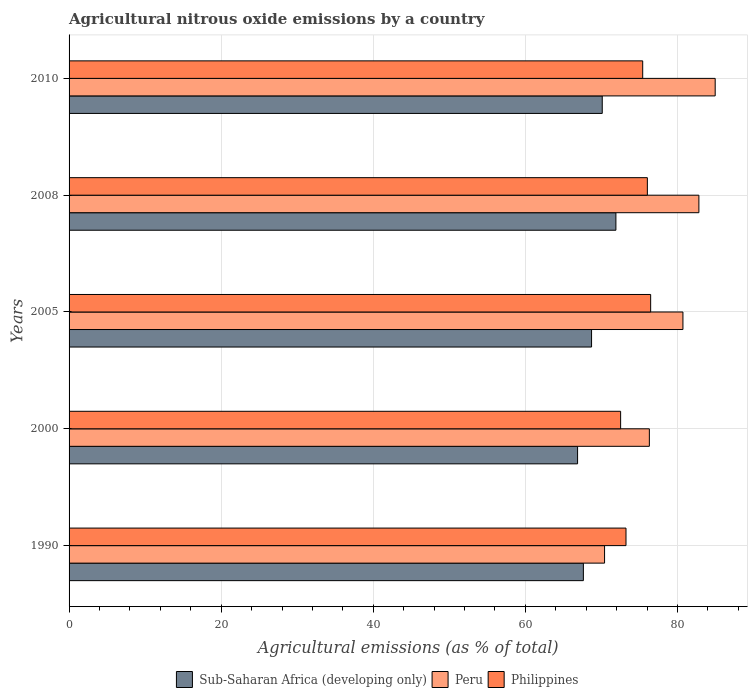Are the number of bars on each tick of the Y-axis equal?
Give a very brief answer. Yes. How many bars are there on the 2nd tick from the top?
Keep it short and to the point. 3. How many bars are there on the 5th tick from the bottom?
Give a very brief answer. 3. What is the label of the 1st group of bars from the top?
Your answer should be very brief. 2010. In how many cases, is the number of bars for a given year not equal to the number of legend labels?
Make the answer very short. 0. What is the amount of agricultural nitrous oxide emitted in Peru in 2010?
Provide a short and direct response. 84.95. Across all years, what is the maximum amount of agricultural nitrous oxide emitted in Peru?
Your answer should be compact. 84.95. Across all years, what is the minimum amount of agricultural nitrous oxide emitted in Sub-Saharan Africa (developing only)?
Your response must be concise. 66.86. In which year was the amount of agricultural nitrous oxide emitted in Philippines minimum?
Your response must be concise. 2000. What is the total amount of agricultural nitrous oxide emitted in Philippines in the graph?
Provide a short and direct response. 373.66. What is the difference between the amount of agricultural nitrous oxide emitted in Sub-Saharan Africa (developing only) in 2005 and that in 2008?
Your response must be concise. -3.2. What is the difference between the amount of agricultural nitrous oxide emitted in Peru in 2010 and the amount of agricultural nitrous oxide emitted in Sub-Saharan Africa (developing only) in 2008?
Make the answer very short. 13.05. What is the average amount of agricultural nitrous oxide emitted in Peru per year?
Provide a short and direct response. 79.03. In the year 2008, what is the difference between the amount of agricultural nitrous oxide emitted in Peru and amount of agricultural nitrous oxide emitted in Sub-Saharan Africa (developing only)?
Give a very brief answer. 10.91. In how many years, is the amount of agricultural nitrous oxide emitted in Philippines greater than 68 %?
Ensure brevity in your answer.  5. What is the ratio of the amount of agricultural nitrous oxide emitted in Sub-Saharan Africa (developing only) in 2005 to that in 2008?
Provide a short and direct response. 0.96. Is the amount of agricultural nitrous oxide emitted in Peru in 2000 less than that in 2008?
Give a very brief answer. Yes. What is the difference between the highest and the second highest amount of agricultural nitrous oxide emitted in Peru?
Provide a succinct answer. 2.14. What is the difference between the highest and the lowest amount of agricultural nitrous oxide emitted in Sub-Saharan Africa (developing only)?
Provide a succinct answer. 5.04. In how many years, is the amount of agricultural nitrous oxide emitted in Peru greater than the average amount of agricultural nitrous oxide emitted in Peru taken over all years?
Offer a terse response. 3. Is the sum of the amount of agricultural nitrous oxide emitted in Philippines in 1990 and 2005 greater than the maximum amount of agricultural nitrous oxide emitted in Peru across all years?
Make the answer very short. Yes. What does the 2nd bar from the bottom in 2000 represents?
Give a very brief answer. Peru. Is it the case that in every year, the sum of the amount of agricultural nitrous oxide emitted in Peru and amount of agricultural nitrous oxide emitted in Sub-Saharan Africa (developing only) is greater than the amount of agricultural nitrous oxide emitted in Philippines?
Offer a terse response. Yes. How many bars are there?
Keep it short and to the point. 15. Are all the bars in the graph horizontal?
Make the answer very short. Yes. What is the difference between two consecutive major ticks on the X-axis?
Ensure brevity in your answer.  20. Where does the legend appear in the graph?
Offer a terse response. Bottom center. What is the title of the graph?
Keep it short and to the point. Agricultural nitrous oxide emissions by a country. What is the label or title of the X-axis?
Provide a succinct answer. Agricultural emissions (as % of total). What is the Agricultural emissions (as % of total) of Sub-Saharan Africa (developing only) in 1990?
Your answer should be very brief. 67.62. What is the Agricultural emissions (as % of total) in Peru in 1990?
Offer a very short reply. 70.41. What is the Agricultural emissions (as % of total) of Philippines in 1990?
Offer a very short reply. 73.22. What is the Agricultural emissions (as % of total) in Sub-Saharan Africa (developing only) in 2000?
Your answer should be very brief. 66.86. What is the Agricultural emissions (as % of total) in Peru in 2000?
Offer a terse response. 76.3. What is the Agricultural emissions (as % of total) of Philippines in 2000?
Give a very brief answer. 72.52. What is the Agricultural emissions (as % of total) of Sub-Saharan Africa (developing only) in 2005?
Give a very brief answer. 68.7. What is the Agricultural emissions (as % of total) of Peru in 2005?
Provide a short and direct response. 80.71. What is the Agricultural emissions (as % of total) of Philippines in 2005?
Your response must be concise. 76.47. What is the Agricultural emissions (as % of total) of Sub-Saharan Africa (developing only) in 2008?
Offer a very short reply. 71.9. What is the Agricultural emissions (as % of total) of Peru in 2008?
Provide a short and direct response. 82.81. What is the Agricultural emissions (as % of total) of Philippines in 2008?
Ensure brevity in your answer.  76.03. What is the Agricultural emissions (as % of total) in Sub-Saharan Africa (developing only) in 2010?
Offer a terse response. 70.1. What is the Agricultural emissions (as % of total) of Peru in 2010?
Provide a short and direct response. 84.95. What is the Agricultural emissions (as % of total) in Philippines in 2010?
Keep it short and to the point. 75.42. Across all years, what is the maximum Agricultural emissions (as % of total) in Sub-Saharan Africa (developing only)?
Keep it short and to the point. 71.9. Across all years, what is the maximum Agricultural emissions (as % of total) in Peru?
Offer a very short reply. 84.95. Across all years, what is the maximum Agricultural emissions (as % of total) in Philippines?
Provide a succinct answer. 76.47. Across all years, what is the minimum Agricultural emissions (as % of total) in Sub-Saharan Africa (developing only)?
Offer a terse response. 66.86. Across all years, what is the minimum Agricultural emissions (as % of total) of Peru?
Ensure brevity in your answer.  70.41. Across all years, what is the minimum Agricultural emissions (as % of total) of Philippines?
Your answer should be very brief. 72.52. What is the total Agricultural emissions (as % of total) in Sub-Saharan Africa (developing only) in the graph?
Ensure brevity in your answer.  345.18. What is the total Agricultural emissions (as % of total) in Peru in the graph?
Your answer should be compact. 395.17. What is the total Agricultural emissions (as % of total) of Philippines in the graph?
Offer a very short reply. 373.66. What is the difference between the Agricultural emissions (as % of total) of Sub-Saharan Africa (developing only) in 1990 and that in 2000?
Your answer should be very brief. 0.76. What is the difference between the Agricultural emissions (as % of total) of Peru in 1990 and that in 2000?
Provide a short and direct response. -5.89. What is the difference between the Agricultural emissions (as % of total) of Philippines in 1990 and that in 2000?
Your response must be concise. 0.71. What is the difference between the Agricultural emissions (as % of total) in Sub-Saharan Africa (developing only) in 1990 and that in 2005?
Offer a terse response. -1.08. What is the difference between the Agricultural emissions (as % of total) in Peru in 1990 and that in 2005?
Offer a very short reply. -10.3. What is the difference between the Agricultural emissions (as % of total) in Philippines in 1990 and that in 2005?
Your response must be concise. -3.24. What is the difference between the Agricultural emissions (as % of total) of Sub-Saharan Africa (developing only) in 1990 and that in 2008?
Ensure brevity in your answer.  -4.28. What is the difference between the Agricultural emissions (as % of total) of Peru in 1990 and that in 2008?
Provide a succinct answer. -12.4. What is the difference between the Agricultural emissions (as % of total) of Philippines in 1990 and that in 2008?
Your answer should be very brief. -2.81. What is the difference between the Agricultural emissions (as % of total) of Sub-Saharan Africa (developing only) in 1990 and that in 2010?
Keep it short and to the point. -2.48. What is the difference between the Agricultural emissions (as % of total) in Peru in 1990 and that in 2010?
Give a very brief answer. -14.54. What is the difference between the Agricultural emissions (as % of total) in Philippines in 1990 and that in 2010?
Provide a succinct answer. -2.2. What is the difference between the Agricultural emissions (as % of total) in Sub-Saharan Africa (developing only) in 2000 and that in 2005?
Offer a very short reply. -1.84. What is the difference between the Agricultural emissions (as % of total) in Peru in 2000 and that in 2005?
Your answer should be compact. -4.41. What is the difference between the Agricultural emissions (as % of total) in Philippines in 2000 and that in 2005?
Provide a short and direct response. -3.95. What is the difference between the Agricultural emissions (as % of total) of Sub-Saharan Africa (developing only) in 2000 and that in 2008?
Offer a terse response. -5.04. What is the difference between the Agricultural emissions (as % of total) in Peru in 2000 and that in 2008?
Provide a succinct answer. -6.51. What is the difference between the Agricultural emissions (as % of total) of Philippines in 2000 and that in 2008?
Give a very brief answer. -3.52. What is the difference between the Agricultural emissions (as % of total) in Sub-Saharan Africa (developing only) in 2000 and that in 2010?
Offer a very short reply. -3.24. What is the difference between the Agricultural emissions (as % of total) of Peru in 2000 and that in 2010?
Offer a terse response. -8.65. What is the difference between the Agricultural emissions (as % of total) of Philippines in 2000 and that in 2010?
Ensure brevity in your answer.  -2.9. What is the difference between the Agricultural emissions (as % of total) in Sub-Saharan Africa (developing only) in 2005 and that in 2008?
Offer a terse response. -3.2. What is the difference between the Agricultural emissions (as % of total) in Peru in 2005 and that in 2008?
Make the answer very short. -2.1. What is the difference between the Agricultural emissions (as % of total) of Philippines in 2005 and that in 2008?
Offer a very short reply. 0.43. What is the difference between the Agricultural emissions (as % of total) in Sub-Saharan Africa (developing only) in 2005 and that in 2010?
Give a very brief answer. -1.41. What is the difference between the Agricultural emissions (as % of total) of Peru in 2005 and that in 2010?
Offer a terse response. -4.24. What is the difference between the Agricultural emissions (as % of total) of Philippines in 2005 and that in 2010?
Your answer should be very brief. 1.05. What is the difference between the Agricultural emissions (as % of total) of Sub-Saharan Africa (developing only) in 2008 and that in 2010?
Your answer should be compact. 1.79. What is the difference between the Agricultural emissions (as % of total) of Peru in 2008 and that in 2010?
Offer a terse response. -2.14. What is the difference between the Agricultural emissions (as % of total) of Philippines in 2008 and that in 2010?
Make the answer very short. 0.61. What is the difference between the Agricultural emissions (as % of total) of Sub-Saharan Africa (developing only) in 1990 and the Agricultural emissions (as % of total) of Peru in 2000?
Your answer should be very brief. -8.68. What is the difference between the Agricultural emissions (as % of total) of Sub-Saharan Africa (developing only) in 1990 and the Agricultural emissions (as % of total) of Philippines in 2000?
Your response must be concise. -4.9. What is the difference between the Agricultural emissions (as % of total) of Peru in 1990 and the Agricultural emissions (as % of total) of Philippines in 2000?
Ensure brevity in your answer.  -2.11. What is the difference between the Agricultural emissions (as % of total) in Sub-Saharan Africa (developing only) in 1990 and the Agricultural emissions (as % of total) in Peru in 2005?
Offer a terse response. -13.09. What is the difference between the Agricultural emissions (as % of total) of Sub-Saharan Africa (developing only) in 1990 and the Agricultural emissions (as % of total) of Philippines in 2005?
Your answer should be very brief. -8.85. What is the difference between the Agricultural emissions (as % of total) in Peru in 1990 and the Agricultural emissions (as % of total) in Philippines in 2005?
Make the answer very short. -6.06. What is the difference between the Agricultural emissions (as % of total) of Sub-Saharan Africa (developing only) in 1990 and the Agricultural emissions (as % of total) of Peru in 2008?
Offer a very short reply. -15.19. What is the difference between the Agricultural emissions (as % of total) in Sub-Saharan Africa (developing only) in 1990 and the Agricultural emissions (as % of total) in Philippines in 2008?
Keep it short and to the point. -8.41. What is the difference between the Agricultural emissions (as % of total) in Peru in 1990 and the Agricultural emissions (as % of total) in Philippines in 2008?
Your response must be concise. -5.63. What is the difference between the Agricultural emissions (as % of total) in Sub-Saharan Africa (developing only) in 1990 and the Agricultural emissions (as % of total) in Peru in 2010?
Your answer should be compact. -17.33. What is the difference between the Agricultural emissions (as % of total) of Sub-Saharan Africa (developing only) in 1990 and the Agricultural emissions (as % of total) of Philippines in 2010?
Make the answer very short. -7.8. What is the difference between the Agricultural emissions (as % of total) in Peru in 1990 and the Agricultural emissions (as % of total) in Philippines in 2010?
Offer a very short reply. -5.01. What is the difference between the Agricultural emissions (as % of total) of Sub-Saharan Africa (developing only) in 2000 and the Agricultural emissions (as % of total) of Peru in 2005?
Offer a terse response. -13.85. What is the difference between the Agricultural emissions (as % of total) in Sub-Saharan Africa (developing only) in 2000 and the Agricultural emissions (as % of total) in Philippines in 2005?
Offer a terse response. -9.61. What is the difference between the Agricultural emissions (as % of total) in Peru in 2000 and the Agricultural emissions (as % of total) in Philippines in 2005?
Provide a succinct answer. -0.17. What is the difference between the Agricultural emissions (as % of total) of Sub-Saharan Africa (developing only) in 2000 and the Agricultural emissions (as % of total) of Peru in 2008?
Your answer should be compact. -15.95. What is the difference between the Agricultural emissions (as % of total) in Sub-Saharan Africa (developing only) in 2000 and the Agricultural emissions (as % of total) in Philippines in 2008?
Offer a very short reply. -9.18. What is the difference between the Agricultural emissions (as % of total) in Peru in 2000 and the Agricultural emissions (as % of total) in Philippines in 2008?
Ensure brevity in your answer.  0.26. What is the difference between the Agricultural emissions (as % of total) of Sub-Saharan Africa (developing only) in 2000 and the Agricultural emissions (as % of total) of Peru in 2010?
Offer a very short reply. -18.09. What is the difference between the Agricultural emissions (as % of total) of Sub-Saharan Africa (developing only) in 2000 and the Agricultural emissions (as % of total) of Philippines in 2010?
Make the answer very short. -8.56. What is the difference between the Agricultural emissions (as % of total) in Peru in 2000 and the Agricultural emissions (as % of total) in Philippines in 2010?
Give a very brief answer. 0.88. What is the difference between the Agricultural emissions (as % of total) of Sub-Saharan Africa (developing only) in 2005 and the Agricultural emissions (as % of total) of Peru in 2008?
Your answer should be very brief. -14.11. What is the difference between the Agricultural emissions (as % of total) of Sub-Saharan Africa (developing only) in 2005 and the Agricultural emissions (as % of total) of Philippines in 2008?
Ensure brevity in your answer.  -7.34. What is the difference between the Agricultural emissions (as % of total) of Peru in 2005 and the Agricultural emissions (as % of total) of Philippines in 2008?
Your response must be concise. 4.68. What is the difference between the Agricultural emissions (as % of total) in Sub-Saharan Africa (developing only) in 2005 and the Agricultural emissions (as % of total) in Peru in 2010?
Ensure brevity in your answer.  -16.25. What is the difference between the Agricultural emissions (as % of total) in Sub-Saharan Africa (developing only) in 2005 and the Agricultural emissions (as % of total) in Philippines in 2010?
Your answer should be very brief. -6.72. What is the difference between the Agricultural emissions (as % of total) of Peru in 2005 and the Agricultural emissions (as % of total) of Philippines in 2010?
Your response must be concise. 5.29. What is the difference between the Agricultural emissions (as % of total) of Sub-Saharan Africa (developing only) in 2008 and the Agricultural emissions (as % of total) of Peru in 2010?
Your answer should be compact. -13.05. What is the difference between the Agricultural emissions (as % of total) of Sub-Saharan Africa (developing only) in 2008 and the Agricultural emissions (as % of total) of Philippines in 2010?
Give a very brief answer. -3.52. What is the difference between the Agricultural emissions (as % of total) in Peru in 2008 and the Agricultural emissions (as % of total) in Philippines in 2010?
Provide a succinct answer. 7.39. What is the average Agricultural emissions (as % of total) in Sub-Saharan Africa (developing only) per year?
Provide a short and direct response. 69.04. What is the average Agricultural emissions (as % of total) in Peru per year?
Provide a succinct answer. 79.03. What is the average Agricultural emissions (as % of total) in Philippines per year?
Provide a short and direct response. 74.73. In the year 1990, what is the difference between the Agricultural emissions (as % of total) in Sub-Saharan Africa (developing only) and Agricultural emissions (as % of total) in Peru?
Your answer should be compact. -2.79. In the year 1990, what is the difference between the Agricultural emissions (as % of total) of Sub-Saharan Africa (developing only) and Agricultural emissions (as % of total) of Philippines?
Ensure brevity in your answer.  -5.6. In the year 1990, what is the difference between the Agricultural emissions (as % of total) of Peru and Agricultural emissions (as % of total) of Philippines?
Your response must be concise. -2.82. In the year 2000, what is the difference between the Agricultural emissions (as % of total) in Sub-Saharan Africa (developing only) and Agricultural emissions (as % of total) in Peru?
Give a very brief answer. -9.44. In the year 2000, what is the difference between the Agricultural emissions (as % of total) in Sub-Saharan Africa (developing only) and Agricultural emissions (as % of total) in Philippines?
Give a very brief answer. -5.66. In the year 2000, what is the difference between the Agricultural emissions (as % of total) in Peru and Agricultural emissions (as % of total) in Philippines?
Your answer should be very brief. 3.78. In the year 2005, what is the difference between the Agricultural emissions (as % of total) in Sub-Saharan Africa (developing only) and Agricultural emissions (as % of total) in Peru?
Provide a succinct answer. -12.01. In the year 2005, what is the difference between the Agricultural emissions (as % of total) of Sub-Saharan Africa (developing only) and Agricultural emissions (as % of total) of Philippines?
Your answer should be very brief. -7.77. In the year 2005, what is the difference between the Agricultural emissions (as % of total) of Peru and Agricultural emissions (as % of total) of Philippines?
Give a very brief answer. 4.24. In the year 2008, what is the difference between the Agricultural emissions (as % of total) in Sub-Saharan Africa (developing only) and Agricultural emissions (as % of total) in Peru?
Ensure brevity in your answer.  -10.91. In the year 2008, what is the difference between the Agricultural emissions (as % of total) of Sub-Saharan Africa (developing only) and Agricultural emissions (as % of total) of Philippines?
Make the answer very short. -4.14. In the year 2008, what is the difference between the Agricultural emissions (as % of total) in Peru and Agricultural emissions (as % of total) in Philippines?
Ensure brevity in your answer.  6.77. In the year 2010, what is the difference between the Agricultural emissions (as % of total) of Sub-Saharan Africa (developing only) and Agricultural emissions (as % of total) of Peru?
Ensure brevity in your answer.  -14.85. In the year 2010, what is the difference between the Agricultural emissions (as % of total) of Sub-Saharan Africa (developing only) and Agricultural emissions (as % of total) of Philippines?
Give a very brief answer. -5.32. In the year 2010, what is the difference between the Agricultural emissions (as % of total) of Peru and Agricultural emissions (as % of total) of Philippines?
Keep it short and to the point. 9.53. What is the ratio of the Agricultural emissions (as % of total) of Sub-Saharan Africa (developing only) in 1990 to that in 2000?
Provide a short and direct response. 1.01. What is the ratio of the Agricultural emissions (as % of total) of Peru in 1990 to that in 2000?
Your answer should be compact. 0.92. What is the ratio of the Agricultural emissions (as % of total) in Philippines in 1990 to that in 2000?
Give a very brief answer. 1.01. What is the ratio of the Agricultural emissions (as % of total) of Sub-Saharan Africa (developing only) in 1990 to that in 2005?
Ensure brevity in your answer.  0.98. What is the ratio of the Agricultural emissions (as % of total) in Peru in 1990 to that in 2005?
Provide a succinct answer. 0.87. What is the ratio of the Agricultural emissions (as % of total) of Philippines in 1990 to that in 2005?
Your answer should be very brief. 0.96. What is the ratio of the Agricultural emissions (as % of total) in Sub-Saharan Africa (developing only) in 1990 to that in 2008?
Your answer should be very brief. 0.94. What is the ratio of the Agricultural emissions (as % of total) in Peru in 1990 to that in 2008?
Provide a short and direct response. 0.85. What is the ratio of the Agricultural emissions (as % of total) of Philippines in 1990 to that in 2008?
Provide a succinct answer. 0.96. What is the ratio of the Agricultural emissions (as % of total) of Sub-Saharan Africa (developing only) in 1990 to that in 2010?
Offer a very short reply. 0.96. What is the ratio of the Agricultural emissions (as % of total) of Peru in 1990 to that in 2010?
Make the answer very short. 0.83. What is the ratio of the Agricultural emissions (as % of total) in Philippines in 1990 to that in 2010?
Give a very brief answer. 0.97. What is the ratio of the Agricultural emissions (as % of total) of Sub-Saharan Africa (developing only) in 2000 to that in 2005?
Give a very brief answer. 0.97. What is the ratio of the Agricultural emissions (as % of total) in Peru in 2000 to that in 2005?
Your answer should be compact. 0.95. What is the ratio of the Agricultural emissions (as % of total) in Philippines in 2000 to that in 2005?
Make the answer very short. 0.95. What is the ratio of the Agricultural emissions (as % of total) of Sub-Saharan Africa (developing only) in 2000 to that in 2008?
Offer a very short reply. 0.93. What is the ratio of the Agricultural emissions (as % of total) of Peru in 2000 to that in 2008?
Offer a terse response. 0.92. What is the ratio of the Agricultural emissions (as % of total) in Philippines in 2000 to that in 2008?
Ensure brevity in your answer.  0.95. What is the ratio of the Agricultural emissions (as % of total) in Sub-Saharan Africa (developing only) in 2000 to that in 2010?
Make the answer very short. 0.95. What is the ratio of the Agricultural emissions (as % of total) of Peru in 2000 to that in 2010?
Offer a very short reply. 0.9. What is the ratio of the Agricultural emissions (as % of total) of Philippines in 2000 to that in 2010?
Offer a terse response. 0.96. What is the ratio of the Agricultural emissions (as % of total) in Sub-Saharan Africa (developing only) in 2005 to that in 2008?
Offer a terse response. 0.96. What is the ratio of the Agricultural emissions (as % of total) of Peru in 2005 to that in 2008?
Give a very brief answer. 0.97. What is the ratio of the Agricultural emissions (as % of total) in Sub-Saharan Africa (developing only) in 2005 to that in 2010?
Offer a terse response. 0.98. What is the ratio of the Agricultural emissions (as % of total) of Peru in 2005 to that in 2010?
Make the answer very short. 0.95. What is the ratio of the Agricultural emissions (as % of total) of Philippines in 2005 to that in 2010?
Your answer should be compact. 1.01. What is the ratio of the Agricultural emissions (as % of total) of Sub-Saharan Africa (developing only) in 2008 to that in 2010?
Make the answer very short. 1.03. What is the ratio of the Agricultural emissions (as % of total) of Peru in 2008 to that in 2010?
Keep it short and to the point. 0.97. What is the difference between the highest and the second highest Agricultural emissions (as % of total) of Sub-Saharan Africa (developing only)?
Give a very brief answer. 1.79. What is the difference between the highest and the second highest Agricultural emissions (as % of total) in Peru?
Make the answer very short. 2.14. What is the difference between the highest and the second highest Agricultural emissions (as % of total) in Philippines?
Offer a very short reply. 0.43. What is the difference between the highest and the lowest Agricultural emissions (as % of total) of Sub-Saharan Africa (developing only)?
Ensure brevity in your answer.  5.04. What is the difference between the highest and the lowest Agricultural emissions (as % of total) in Peru?
Make the answer very short. 14.54. What is the difference between the highest and the lowest Agricultural emissions (as % of total) in Philippines?
Provide a succinct answer. 3.95. 